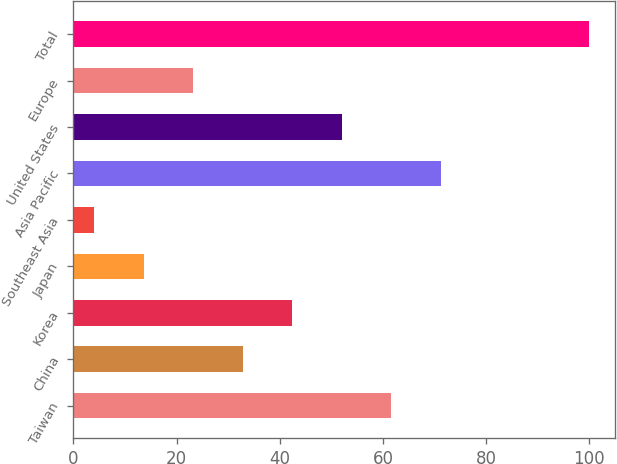<chart> <loc_0><loc_0><loc_500><loc_500><bar_chart><fcel>Taiwan<fcel>China<fcel>Korea<fcel>Japan<fcel>Southeast Asia<fcel>Asia Pacific<fcel>United States<fcel>Europe<fcel>Total<nl><fcel>61.6<fcel>32.8<fcel>42.4<fcel>13.6<fcel>4<fcel>71.2<fcel>52<fcel>23.2<fcel>100<nl></chart> 